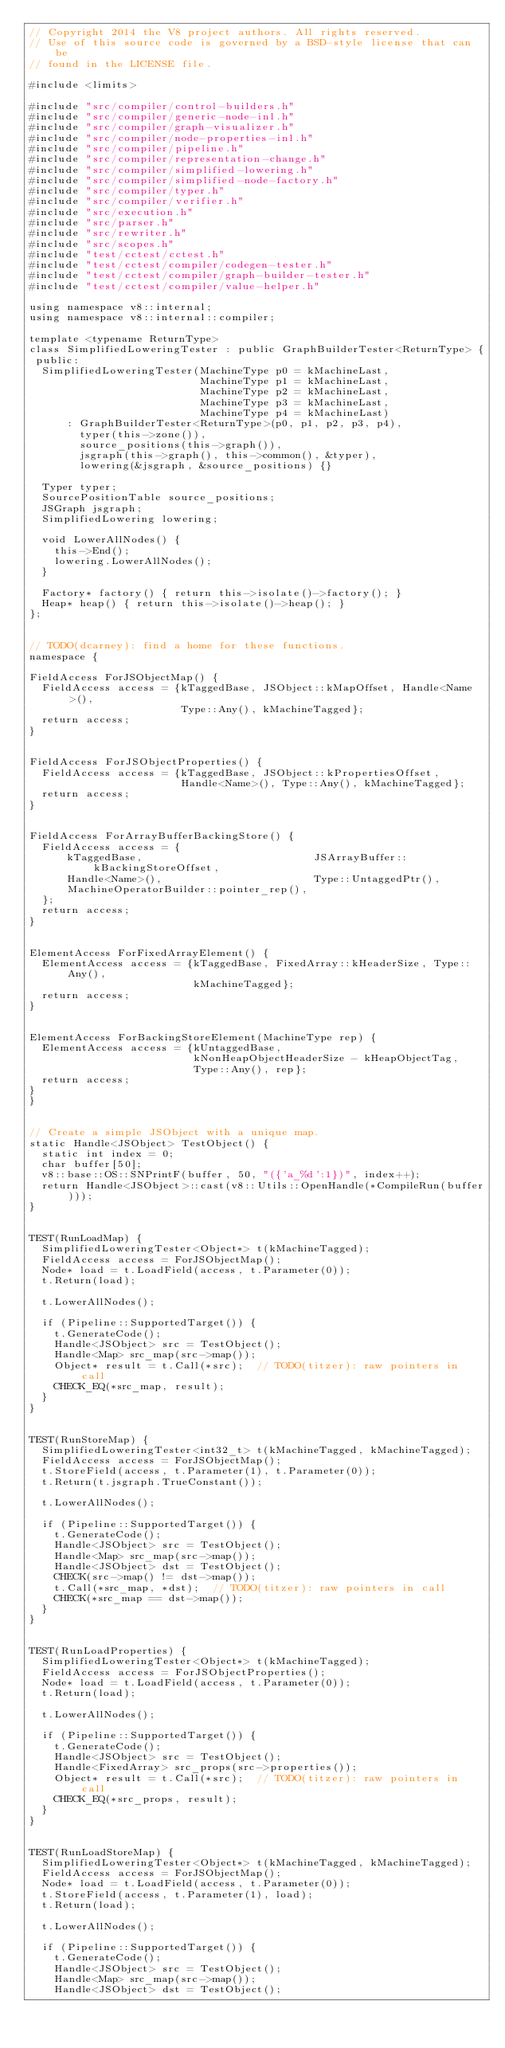<code> <loc_0><loc_0><loc_500><loc_500><_C++_>// Copyright 2014 the V8 project authors. All rights reserved.
// Use of this source code is governed by a BSD-style license that can be
// found in the LICENSE file.

#include <limits>

#include "src/compiler/control-builders.h"
#include "src/compiler/generic-node-inl.h"
#include "src/compiler/graph-visualizer.h"
#include "src/compiler/node-properties-inl.h"
#include "src/compiler/pipeline.h"
#include "src/compiler/representation-change.h"
#include "src/compiler/simplified-lowering.h"
#include "src/compiler/simplified-node-factory.h"
#include "src/compiler/typer.h"
#include "src/compiler/verifier.h"
#include "src/execution.h"
#include "src/parser.h"
#include "src/rewriter.h"
#include "src/scopes.h"
#include "test/cctest/cctest.h"
#include "test/cctest/compiler/codegen-tester.h"
#include "test/cctest/compiler/graph-builder-tester.h"
#include "test/cctest/compiler/value-helper.h"

using namespace v8::internal;
using namespace v8::internal::compiler;

template <typename ReturnType>
class SimplifiedLoweringTester : public GraphBuilderTester<ReturnType> {
 public:
  SimplifiedLoweringTester(MachineType p0 = kMachineLast,
                           MachineType p1 = kMachineLast,
                           MachineType p2 = kMachineLast,
                           MachineType p3 = kMachineLast,
                           MachineType p4 = kMachineLast)
      : GraphBuilderTester<ReturnType>(p0, p1, p2, p3, p4),
        typer(this->zone()),
        source_positions(this->graph()),
        jsgraph(this->graph(), this->common(), &typer),
        lowering(&jsgraph, &source_positions) {}

  Typer typer;
  SourcePositionTable source_positions;
  JSGraph jsgraph;
  SimplifiedLowering lowering;

  void LowerAllNodes() {
    this->End();
    lowering.LowerAllNodes();
  }

  Factory* factory() { return this->isolate()->factory(); }
  Heap* heap() { return this->isolate()->heap(); }
};


// TODO(dcarney): find a home for these functions.
namespace {

FieldAccess ForJSObjectMap() {
  FieldAccess access = {kTaggedBase, JSObject::kMapOffset, Handle<Name>(),
                        Type::Any(), kMachineTagged};
  return access;
}


FieldAccess ForJSObjectProperties() {
  FieldAccess access = {kTaggedBase, JSObject::kPropertiesOffset,
                        Handle<Name>(), Type::Any(), kMachineTagged};
  return access;
}


FieldAccess ForArrayBufferBackingStore() {
  FieldAccess access = {
      kTaggedBase,                           JSArrayBuffer::kBackingStoreOffset,
      Handle<Name>(),                        Type::UntaggedPtr(),
      MachineOperatorBuilder::pointer_rep(),
  };
  return access;
}


ElementAccess ForFixedArrayElement() {
  ElementAccess access = {kTaggedBase, FixedArray::kHeaderSize, Type::Any(),
                          kMachineTagged};
  return access;
}


ElementAccess ForBackingStoreElement(MachineType rep) {
  ElementAccess access = {kUntaggedBase,
                          kNonHeapObjectHeaderSize - kHeapObjectTag,
                          Type::Any(), rep};
  return access;
}
}


// Create a simple JSObject with a unique map.
static Handle<JSObject> TestObject() {
  static int index = 0;
  char buffer[50];
  v8::base::OS::SNPrintF(buffer, 50, "({'a_%d':1})", index++);
  return Handle<JSObject>::cast(v8::Utils::OpenHandle(*CompileRun(buffer)));
}


TEST(RunLoadMap) {
  SimplifiedLoweringTester<Object*> t(kMachineTagged);
  FieldAccess access = ForJSObjectMap();
  Node* load = t.LoadField(access, t.Parameter(0));
  t.Return(load);

  t.LowerAllNodes();

  if (Pipeline::SupportedTarget()) {
    t.GenerateCode();
    Handle<JSObject> src = TestObject();
    Handle<Map> src_map(src->map());
    Object* result = t.Call(*src);  // TODO(titzer): raw pointers in call
    CHECK_EQ(*src_map, result);
  }
}


TEST(RunStoreMap) {
  SimplifiedLoweringTester<int32_t> t(kMachineTagged, kMachineTagged);
  FieldAccess access = ForJSObjectMap();
  t.StoreField(access, t.Parameter(1), t.Parameter(0));
  t.Return(t.jsgraph.TrueConstant());

  t.LowerAllNodes();

  if (Pipeline::SupportedTarget()) {
    t.GenerateCode();
    Handle<JSObject> src = TestObject();
    Handle<Map> src_map(src->map());
    Handle<JSObject> dst = TestObject();
    CHECK(src->map() != dst->map());
    t.Call(*src_map, *dst);  // TODO(titzer): raw pointers in call
    CHECK(*src_map == dst->map());
  }
}


TEST(RunLoadProperties) {
  SimplifiedLoweringTester<Object*> t(kMachineTagged);
  FieldAccess access = ForJSObjectProperties();
  Node* load = t.LoadField(access, t.Parameter(0));
  t.Return(load);

  t.LowerAllNodes();

  if (Pipeline::SupportedTarget()) {
    t.GenerateCode();
    Handle<JSObject> src = TestObject();
    Handle<FixedArray> src_props(src->properties());
    Object* result = t.Call(*src);  // TODO(titzer): raw pointers in call
    CHECK_EQ(*src_props, result);
  }
}


TEST(RunLoadStoreMap) {
  SimplifiedLoweringTester<Object*> t(kMachineTagged, kMachineTagged);
  FieldAccess access = ForJSObjectMap();
  Node* load = t.LoadField(access, t.Parameter(0));
  t.StoreField(access, t.Parameter(1), load);
  t.Return(load);

  t.LowerAllNodes();

  if (Pipeline::SupportedTarget()) {
    t.GenerateCode();
    Handle<JSObject> src = TestObject();
    Handle<Map> src_map(src->map());
    Handle<JSObject> dst = TestObject();</code> 